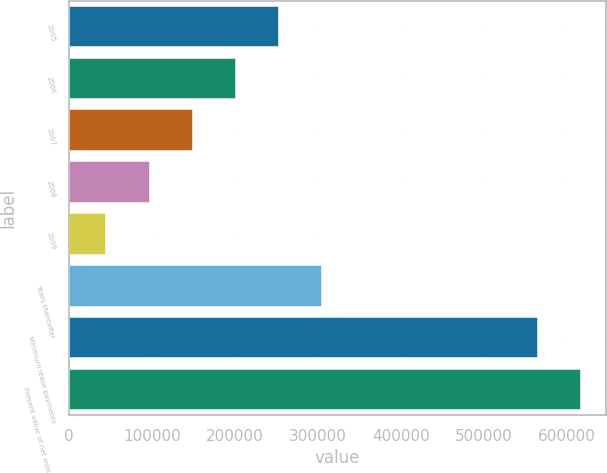Convert chart to OTSL. <chart><loc_0><loc_0><loc_500><loc_500><bar_chart><fcel>2005<fcel>2006<fcel>2007<fcel>2008<fcel>2009<fcel>Years thereafter<fcel>Minimum lease payments<fcel>Present value of net minimum<nl><fcel>252920<fcel>201000<fcel>149080<fcel>97160.1<fcel>45240<fcel>304840<fcel>564441<fcel>616361<nl></chart> 